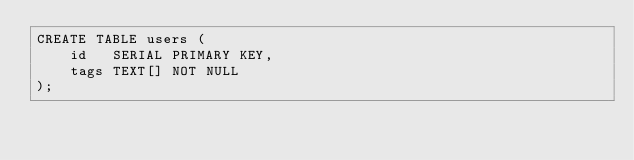<code> <loc_0><loc_0><loc_500><loc_500><_SQL_>CREATE TABLE users (
    id   SERIAL PRIMARY KEY,
    tags TEXT[] NOT NULL
);
</code> 